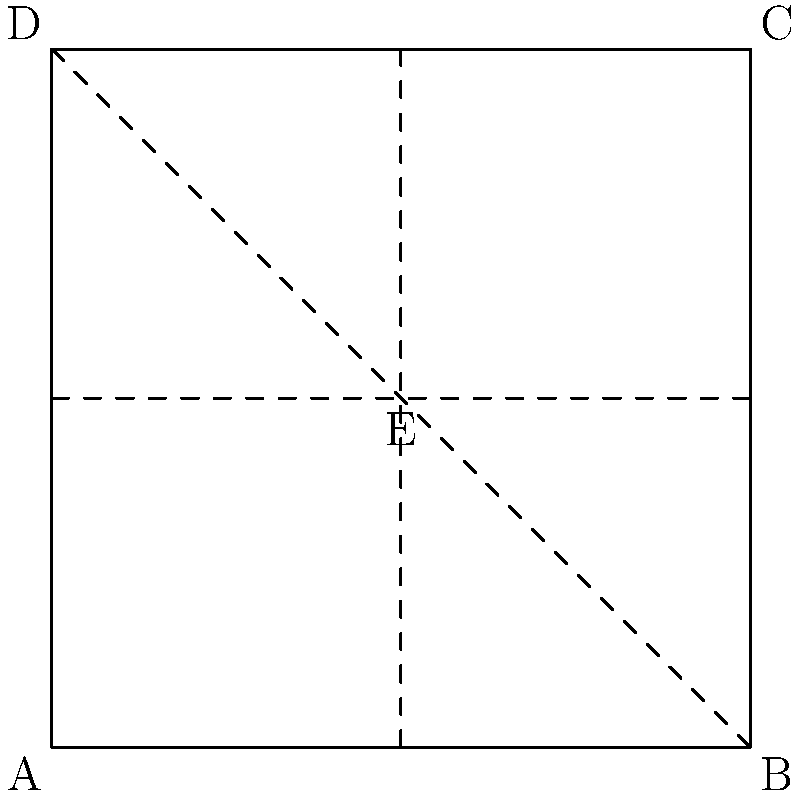In the art of origami, understanding folding patterns is crucial. The diagram shows a square paper with dashed lines indicating fold creases. If you were to fold along these lines in any order, which point would end up at the center of the folded figure? To solve this problem, we need to visualize the folding process:

1. The square is divided into 8 triangular sections by the fold lines.
2. Point E is at the intersection of all three fold lines.
3. Folding along any of the lines will bring two halves of the square together.
4. No matter which order we fold in, all folds will eventually meet at point E.
5. The corners (A, B, C, D) will be folded towards the center.
6. Point E remains stationary throughout the folding process.

Therefore, after all folds are made, point E will be at the center of the folded figure.
Answer: E 